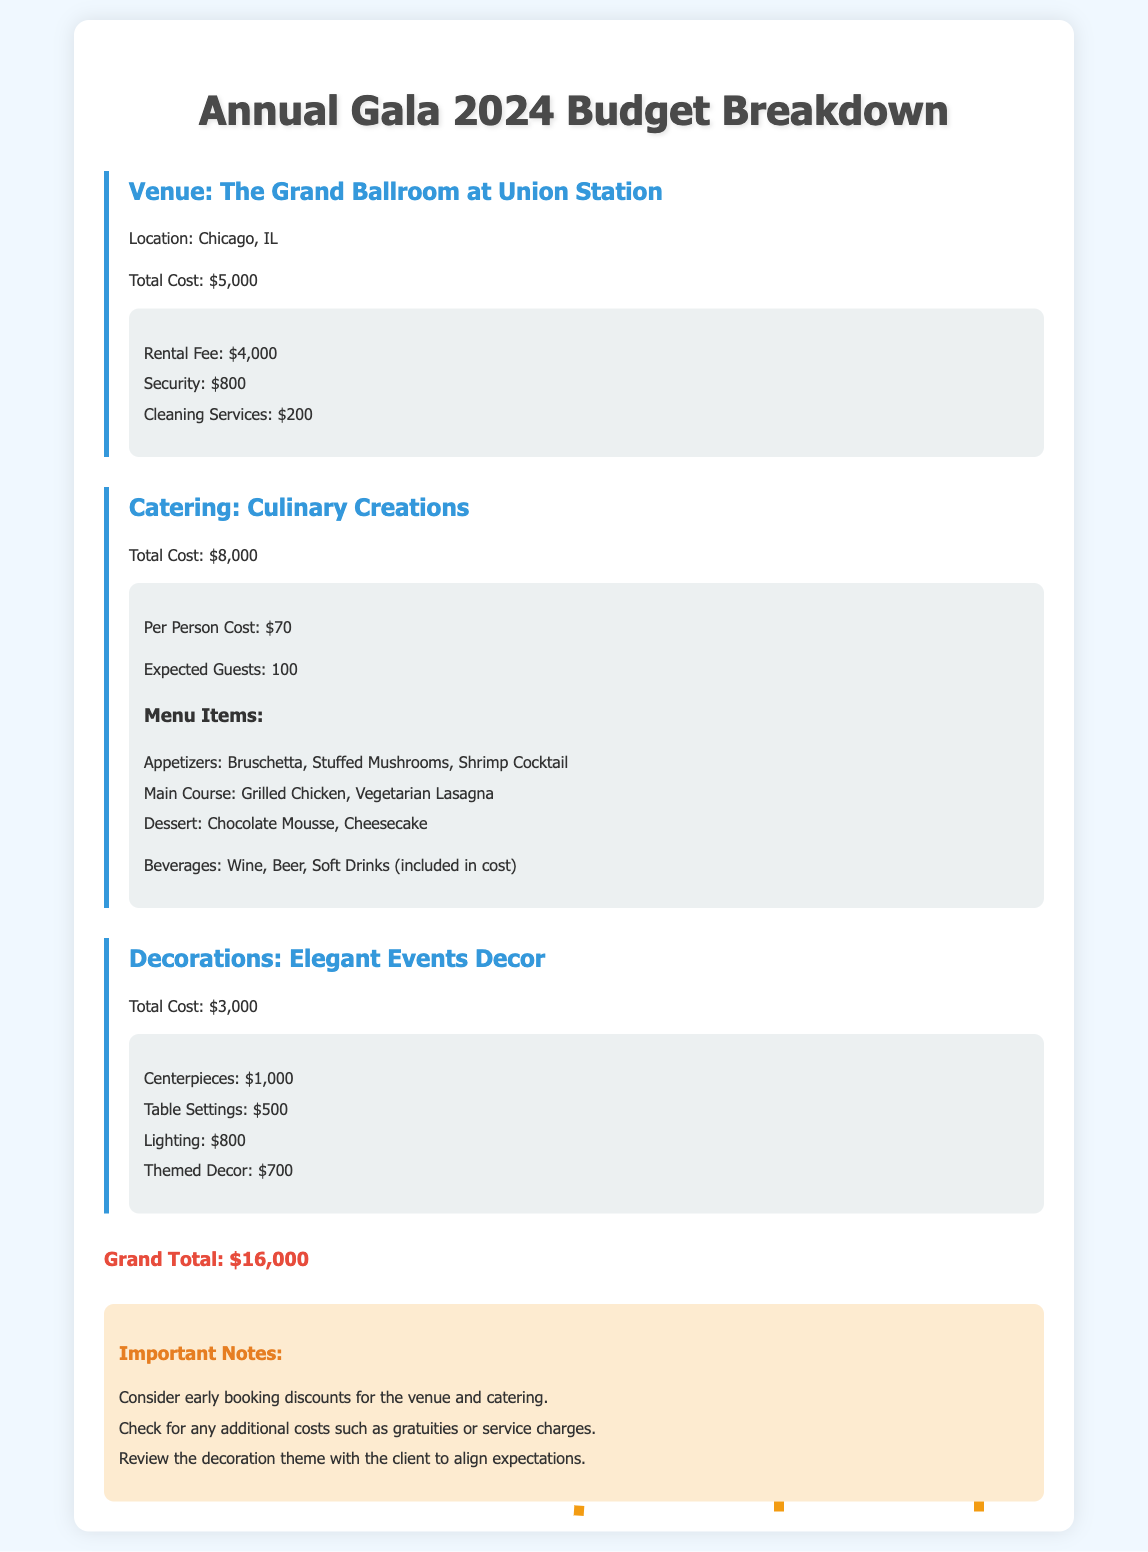What is the total cost for the venue? The total cost for the venue, as mentioned in the document, is $5,000.
Answer: $5,000 How much does each guest cost for catering? The document states that the per person cost for catering is $70.
Answer: $70 What is the grand total for the gala budget? The grand total is the sum of all costs detailed in the document, which is $16,000.
Answer: $16,000 How many expected guests are there for the catering? The expected number of guests for catering is 100, as mentioned in the details.
Answer: 100 What is the total cost for decorations? According to the document, the total cost for decorations is $3,000.
Answer: $3,000 What is included in the catering beverages? The document specifies that wine, beer, and soft drinks are included in the catering cost.
Answer: Wine, Beer, Soft Drinks How much do the centerpieces cost? The cost of the centerpieces is listed as $1,000 in the decorations section.
Answer: $1,000 What are two important notes provided in the document? One important note is to consider early booking discounts and another is to check for additional costs like gratuities.
Answer: Consider early booking discounts, Check for additional costs What menu item is listed under the main course? The document lists Grilled Chicken and Vegetarian Lasagna as menu items under the main course.
Answer: Grilled Chicken, Vegetarian Lasagna 